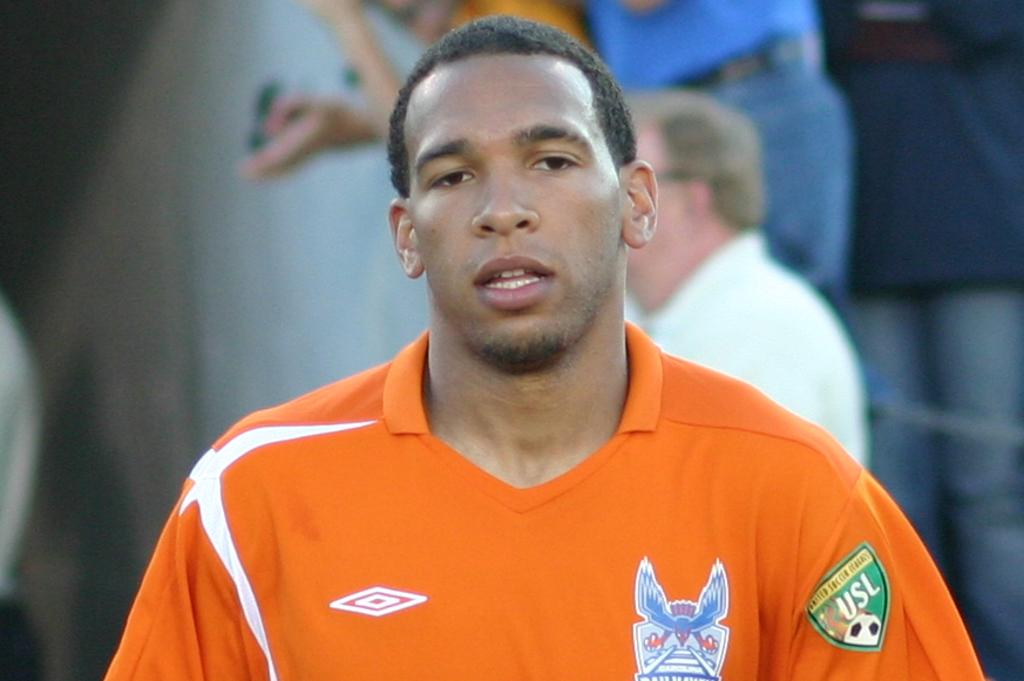<image>
Relay a brief, clear account of the picture shown. the man is wearing an orange jersey with USL on the sleeve 